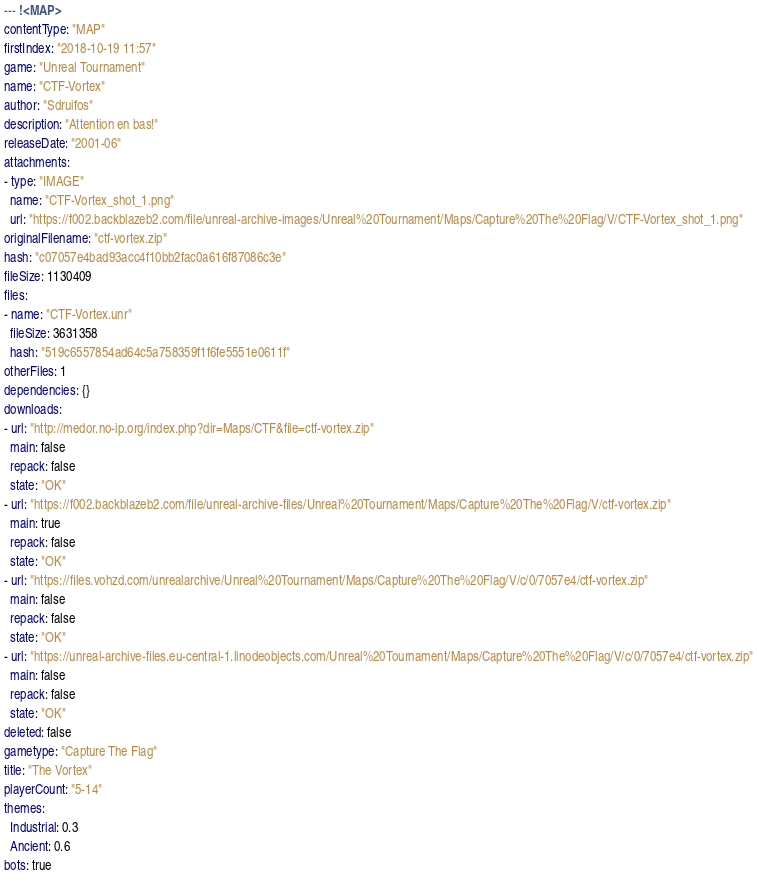Convert code to text. <code><loc_0><loc_0><loc_500><loc_500><_YAML_>--- !<MAP>
contentType: "MAP"
firstIndex: "2018-10-19 11:57"
game: "Unreal Tournament"
name: "CTF-Vortex"
author: "Sdruifos"
description: "Attention en bas!"
releaseDate: "2001-06"
attachments:
- type: "IMAGE"
  name: "CTF-Vortex_shot_1.png"
  url: "https://f002.backblazeb2.com/file/unreal-archive-images/Unreal%20Tournament/Maps/Capture%20The%20Flag/V/CTF-Vortex_shot_1.png"
originalFilename: "ctf-vortex.zip"
hash: "c07057e4bad93acc4f10bb2fac0a616f87086c3e"
fileSize: 1130409
files:
- name: "CTF-Vortex.unr"
  fileSize: 3631358
  hash: "519c6557854ad64c5a758359f1f6fe5551e0611f"
otherFiles: 1
dependencies: {}
downloads:
- url: "http://medor.no-ip.org/index.php?dir=Maps/CTF&file=ctf-vortex.zip"
  main: false
  repack: false
  state: "OK"
- url: "https://f002.backblazeb2.com/file/unreal-archive-files/Unreal%20Tournament/Maps/Capture%20The%20Flag/V/ctf-vortex.zip"
  main: true
  repack: false
  state: "OK"
- url: "https://files.vohzd.com/unrealarchive/Unreal%20Tournament/Maps/Capture%20The%20Flag/V/c/0/7057e4/ctf-vortex.zip"
  main: false
  repack: false
  state: "OK"
- url: "https://unreal-archive-files.eu-central-1.linodeobjects.com/Unreal%20Tournament/Maps/Capture%20The%20Flag/V/c/0/7057e4/ctf-vortex.zip"
  main: false
  repack: false
  state: "OK"
deleted: false
gametype: "Capture The Flag"
title: "The Vortex"
playerCount: "5-14"
themes:
  Industrial: 0.3
  Ancient: 0.6
bots: true
</code> 